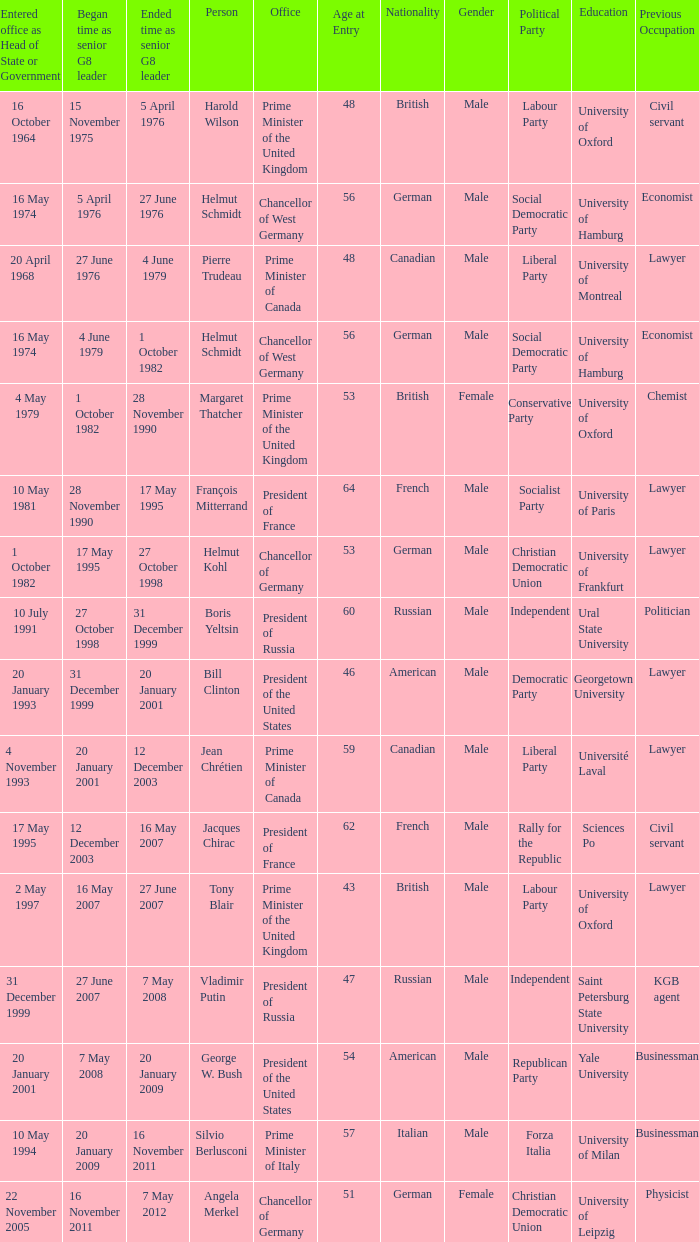When did the Prime Minister of Italy take office? 10 May 1994. 